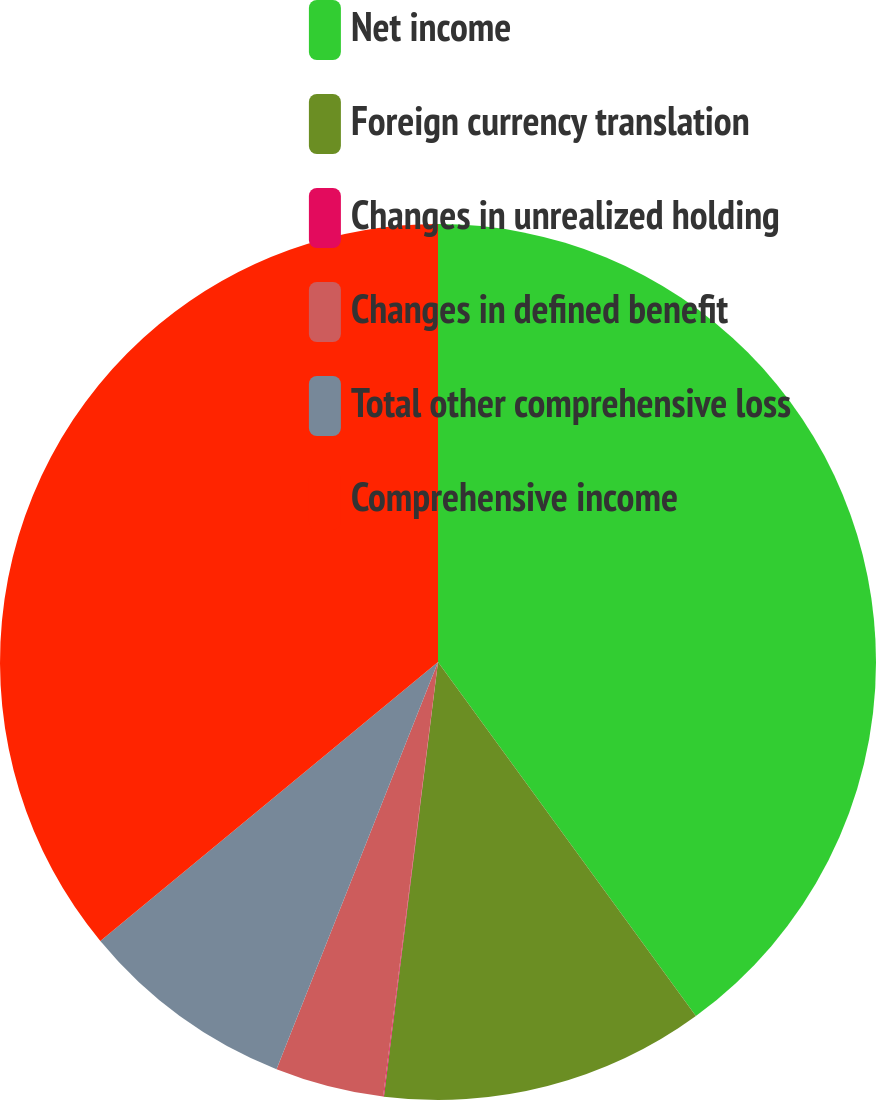<chart> <loc_0><loc_0><loc_500><loc_500><pie_chart><fcel>Net income<fcel>Foreign currency translation<fcel>Changes in unrealized holding<fcel>Changes in defined benefit<fcel>Total other comprehensive loss<fcel>Comprehensive income<nl><fcel>39.98%<fcel>11.99%<fcel>0.03%<fcel>4.01%<fcel>8.0%<fcel>35.99%<nl></chart> 